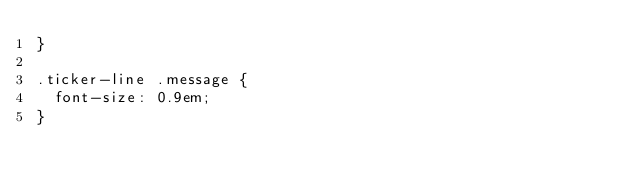Convert code to text. <code><loc_0><loc_0><loc_500><loc_500><_CSS_>}

.ticker-line .message {
  font-size: 0.9em;
}
</code> 